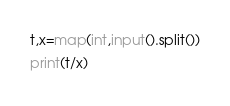<code> <loc_0><loc_0><loc_500><loc_500><_Python_>t,x=map(int,input().split())
print(t/x)</code> 